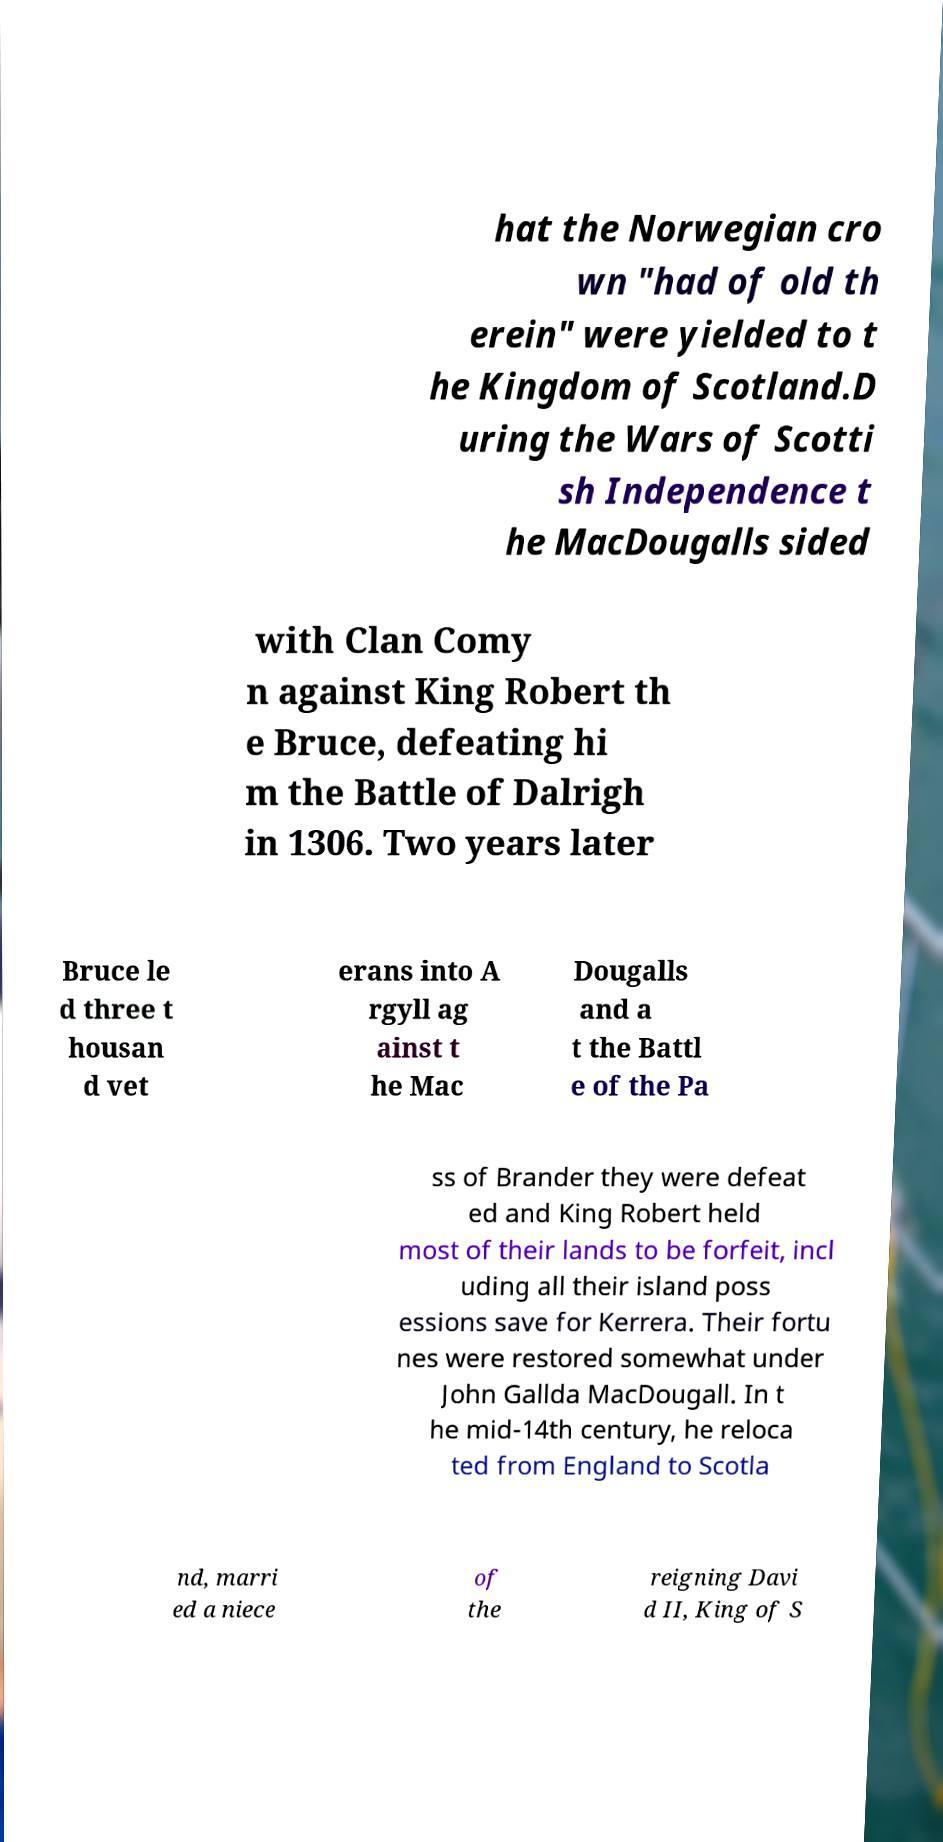There's text embedded in this image that I need extracted. Can you transcribe it verbatim? hat the Norwegian cro wn "had of old th erein" were yielded to t he Kingdom of Scotland.D uring the Wars of Scotti sh Independence t he MacDougalls sided with Clan Comy n against King Robert th e Bruce, defeating hi m the Battle of Dalrigh in 1306. Two years later Bruce le d three t housan d vet erans into A rgyll ag ainst t he Mac Dougalls and a t the Battl e of the Pa ss of Brander they were defeat ed and King Robert held most of their lands to be forfeit, incl uding all their island poss essions save for Kerrera. Their fortu nes were restored somewhat under John Gallda MacDougall. In t he mid-14th century, he reloca ted from England to Scotla nd, marri ed a niece of the reigning Davi d II, King of S 